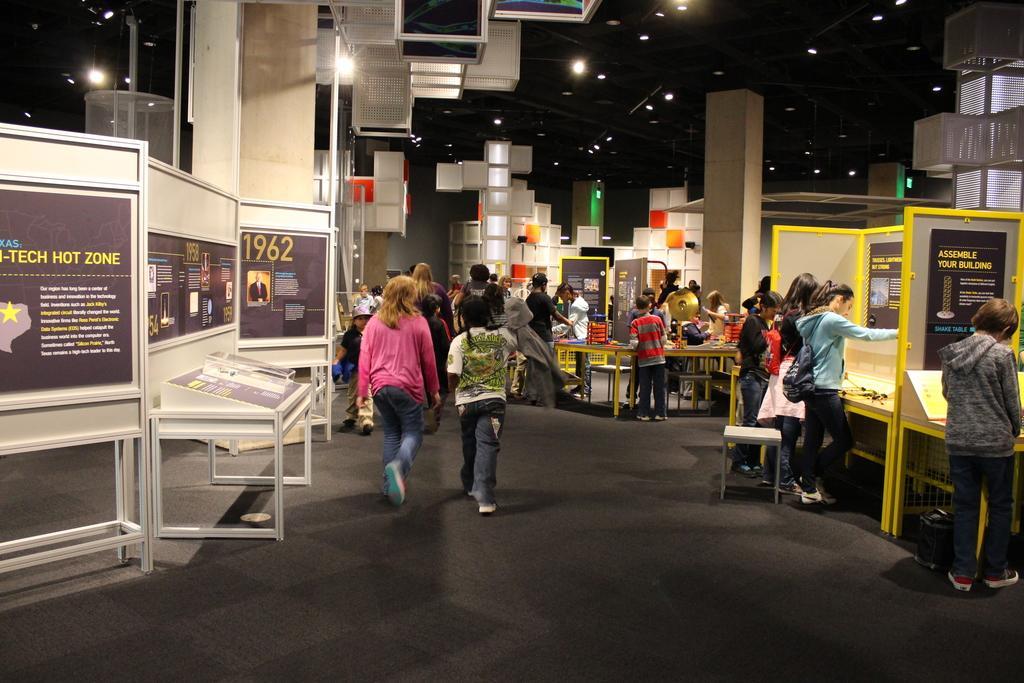Describe this image in one or two sentences. The image might be taken in an exhibition or an expo. In the foreground of the picture there are boards, people, stool and other objects. In the center of the picture there are people, boards, tables, chairs. At the top there are lights and box like objects. In the background there are boxes like things and lights. 